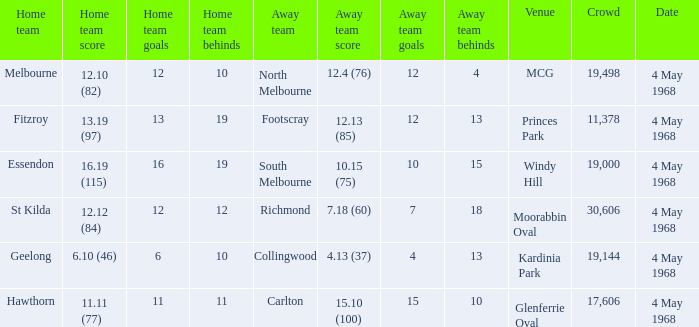What team played at Moorabbin Oval to a crowd of 19,144? St Kilda. 